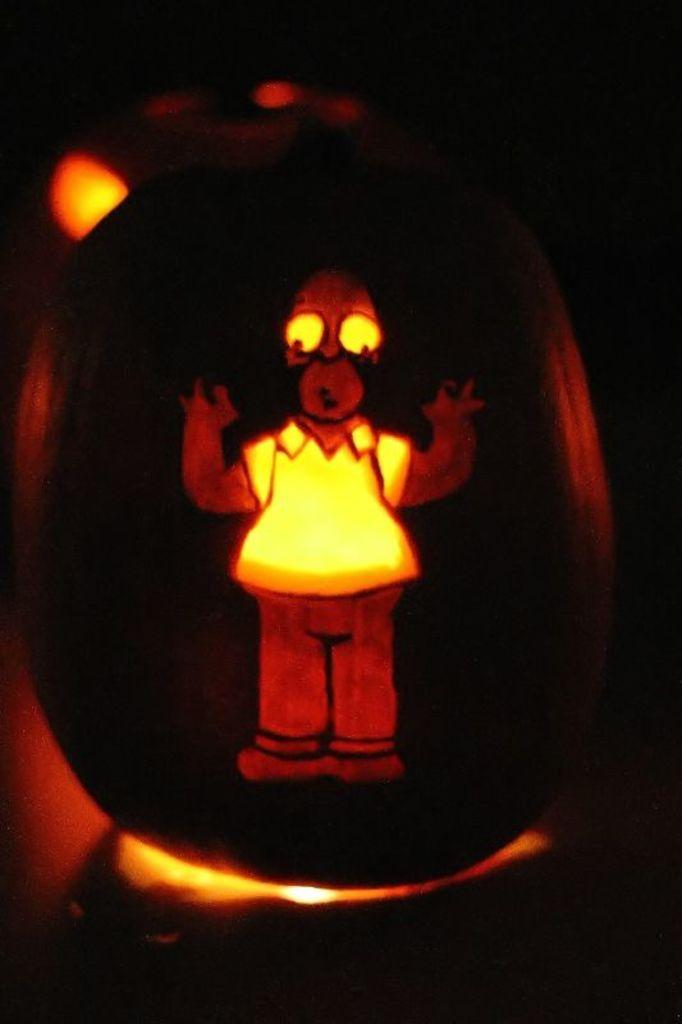What type of picture is in the image? The image contains a cartoon picture. What can be observed about the background of the image? The background of the image is dark. How many twigs are used to create the cartoon character in the image? There are no twigs present in the image, as it contains a cartoon picture and not a drawing made from twigs. 